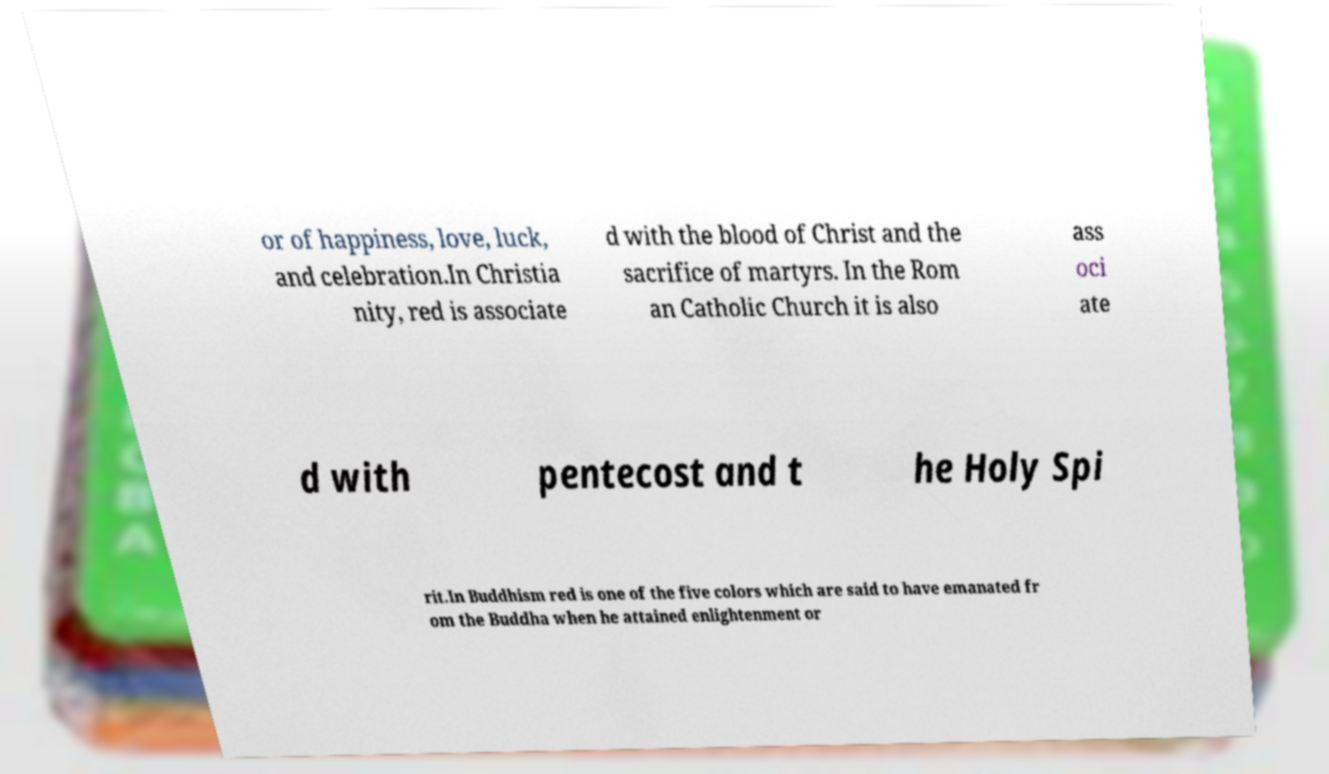What messages or text are displayed in this image? I need them in a readable, typed format. or of happiness, love, luck, and celebration.In Christia nity, red is associate d with the blood of Christ and the sacrifice of martyrs. In the Rom an Catholic Church it is also ass oci ate d with pentecost and t he Holy Spi rit.In Buddhism red is one of the five colors which are said to have emanated fr om the Buddha when he attained enlightenment or 